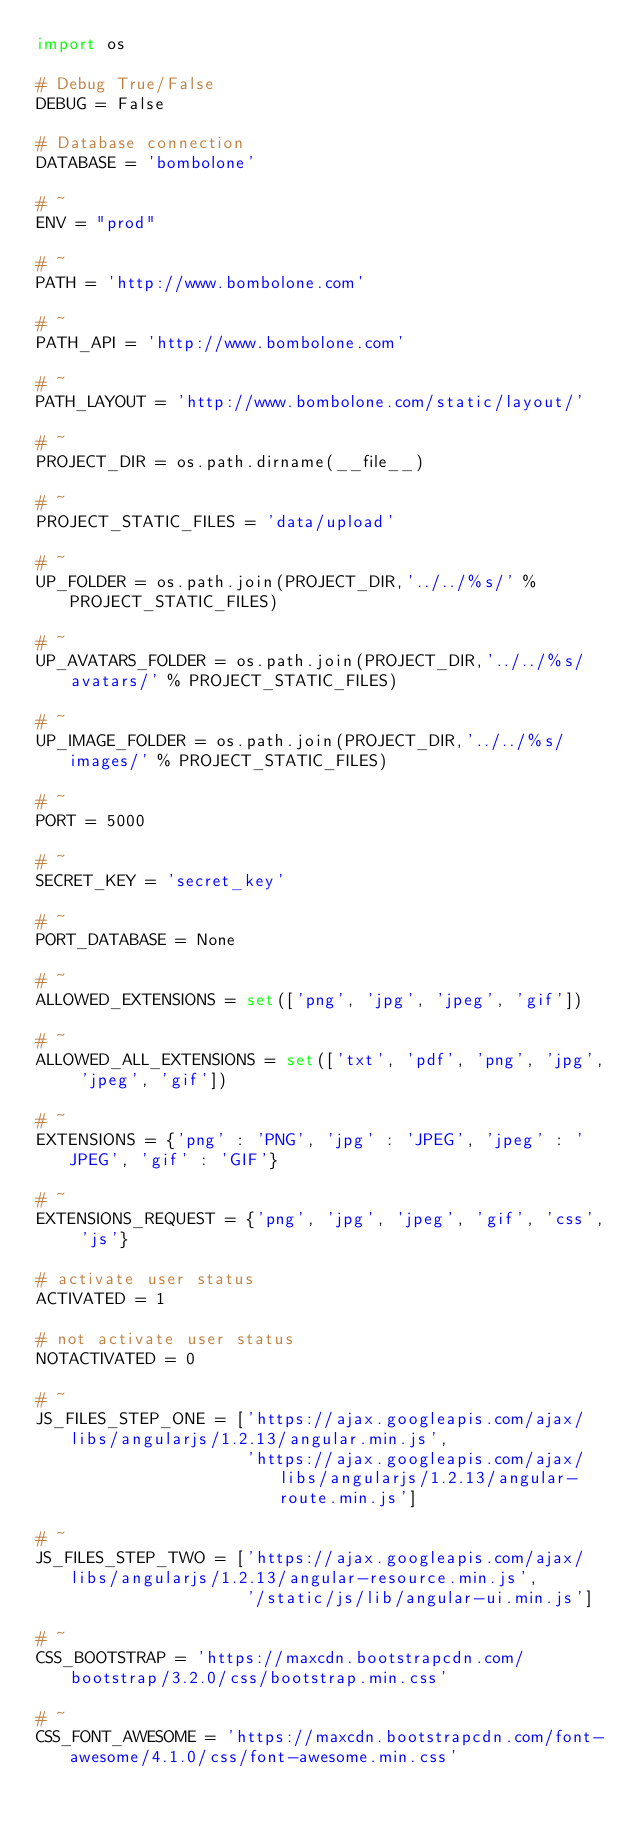Convert code to text. <code><loc_0><loc_0><loc_500><loc_500><_Python_>import os

# Debug True/False
DEBUG = False

# Database connection
DATABASE = 'bombolone'

# ~
ENV = "prod"

# ~
PATH = 'http://www.bombolone.com'

# ~
PATH_API = 'http://www.bombolone.com'

# ~
PATH_LAYOUT = 'http://www.bombolone.com/static/layout/'

# ~
PROJECT_DIR = os.path.dirname(__file__)

# ~
PROJECT_STATIC_FILES = 'data/upload'

# ~
UP_FOLDER = os.path.join(PROJECT_DIR,'../../%s/' % PROJECT_STATIC_FILES)

# ~
UP_AVATARS_FOLDER = os.path.join(PROJECT_DIR,'../../%s/avatars/' % PROJECT_STATIC_FILES)

# ~
UP_IMAGE_FOLDER = os.path.join(PROJECT_DIR,'../../%s/images/' % PROJECT_STATIC_FILES)

# ~
PORT = 5000

# ~
SECRET_KEY = 'secret_key'

# ~
PORT_DATABASE = None

# ~
ALLOWED_EXTENSIONS = set(['png', 'jpg', 'jpeg', 'gif'])

# ~
ALLOWED_ALL_EXTENSIONS = set(['txt', 'pdf', 'png', 'jpg', 'jpeg', 'gif'])

# ~
EXTENSIONS = {'png' : 'PNG', 'jpg' : 'JPEG', 'jpeg' : 'JPEG', 'gif' : 'GIF'}

# ~
EXTENSIONS_REQUEST = {'png', 'jpg', 'jpeg', 'gif', 'css', 'js'}

# activate user status
ACTIVATED = 1

# not activate user status
NOTACTIVATED = 0

# ~
JS_FILES_STEP_ONE = ['https://ajax.googleapis.com/ajax/libs/angularjs/1.2.13/angular.min.js',
                     'https://ajax.googleapis.com/ajax/libs/angularjs/1.2.13/angular-route.min.js']

# ~
JS_FILES_STEP_TWO = ['https://ajax.googleapis.com/ajax/libs/angularjs/1.2.13/angular-resource.min.js',
                     '/static/js/lib/angular-ui.min.js']

# ~
CSS_BOOTSTRAP = 'https://maxcdn.bootstrapcdn.com/bootstrap/3.2.0/css/bootstrap.min.css'

# ~
CSS_FONT_AWESOME = 'https://maxcdn.bootstrapcdn.com/font-awesome/4.1.0/css/font-awesome.min.css'
</code> 